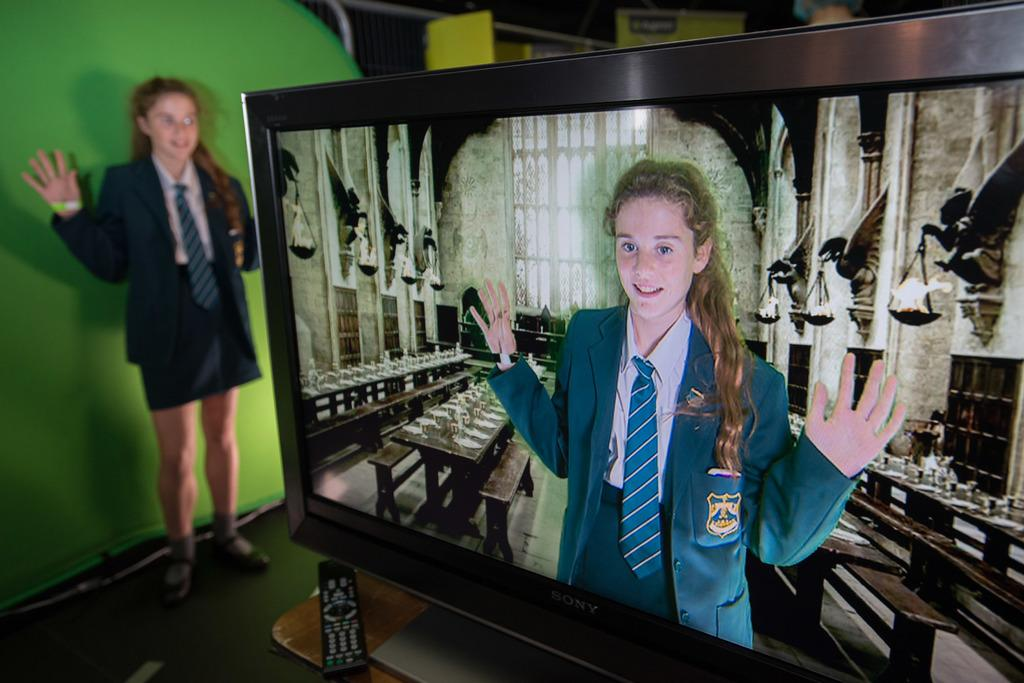What electronic device is present in the image? There is a television in the image. What is being displayed on the television? The television is displaying a picture of a woman wearing a green dress. What might be used to control the television? There is a remote beside the television. Can you describe the woman standing in the image? There is a woman standing in the left corner of the image. What type of love can be seen in the image? There is no love present in the image; it features a television displaying a picture of a woman wearing a green dress and a woman standing in the left corner. What rule is being enforced in the image? There is no rule being enforced in the image; it is a scene with a television and a woman standing nearby. 